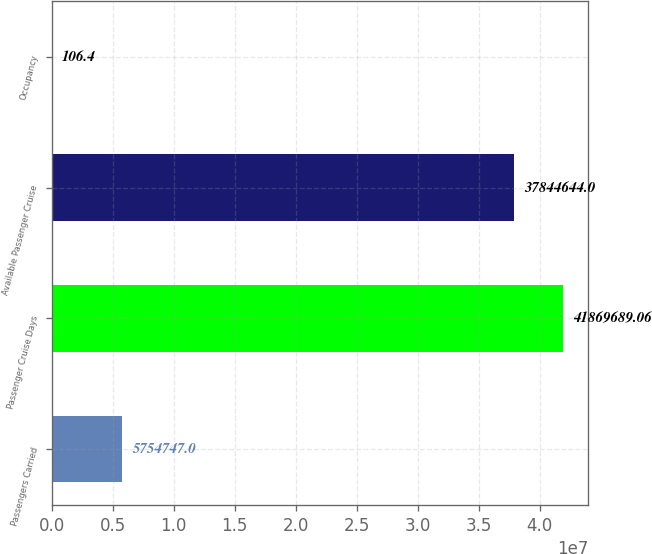Convert chart. <chart><loc_0><loc_0><loc_500><loc_500><bar_chart><fcel>Passengers Carried<fcel>Passenger Cruise Days<fcel>Available Passenger Cruise<fcel>Occupancy<nl><fcel>5.75475e+06<fcel>4.18697e+07<fcel>3.78446e+07<fcel>106.4<nl></chart> 